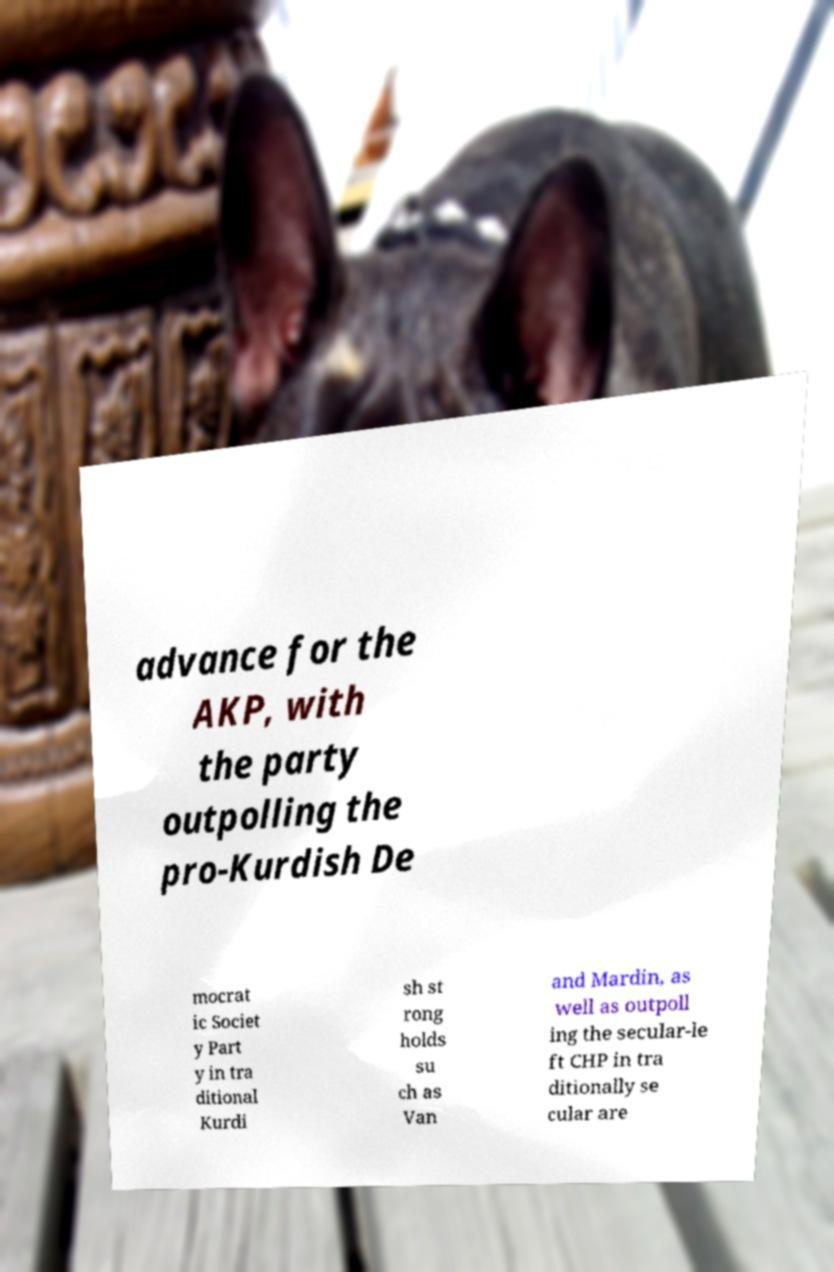Can you accurately transcribe the text from the provided image for me? advance for the AKP, with the party outpolling the pro-Kurdish De mocrat ic Societ y Part y in tra ditional Kurdi sh st rong holds su ch as Van and Mardin, as well as outpoll ing the secular-le ft CHP in tra ditionally se cular are 